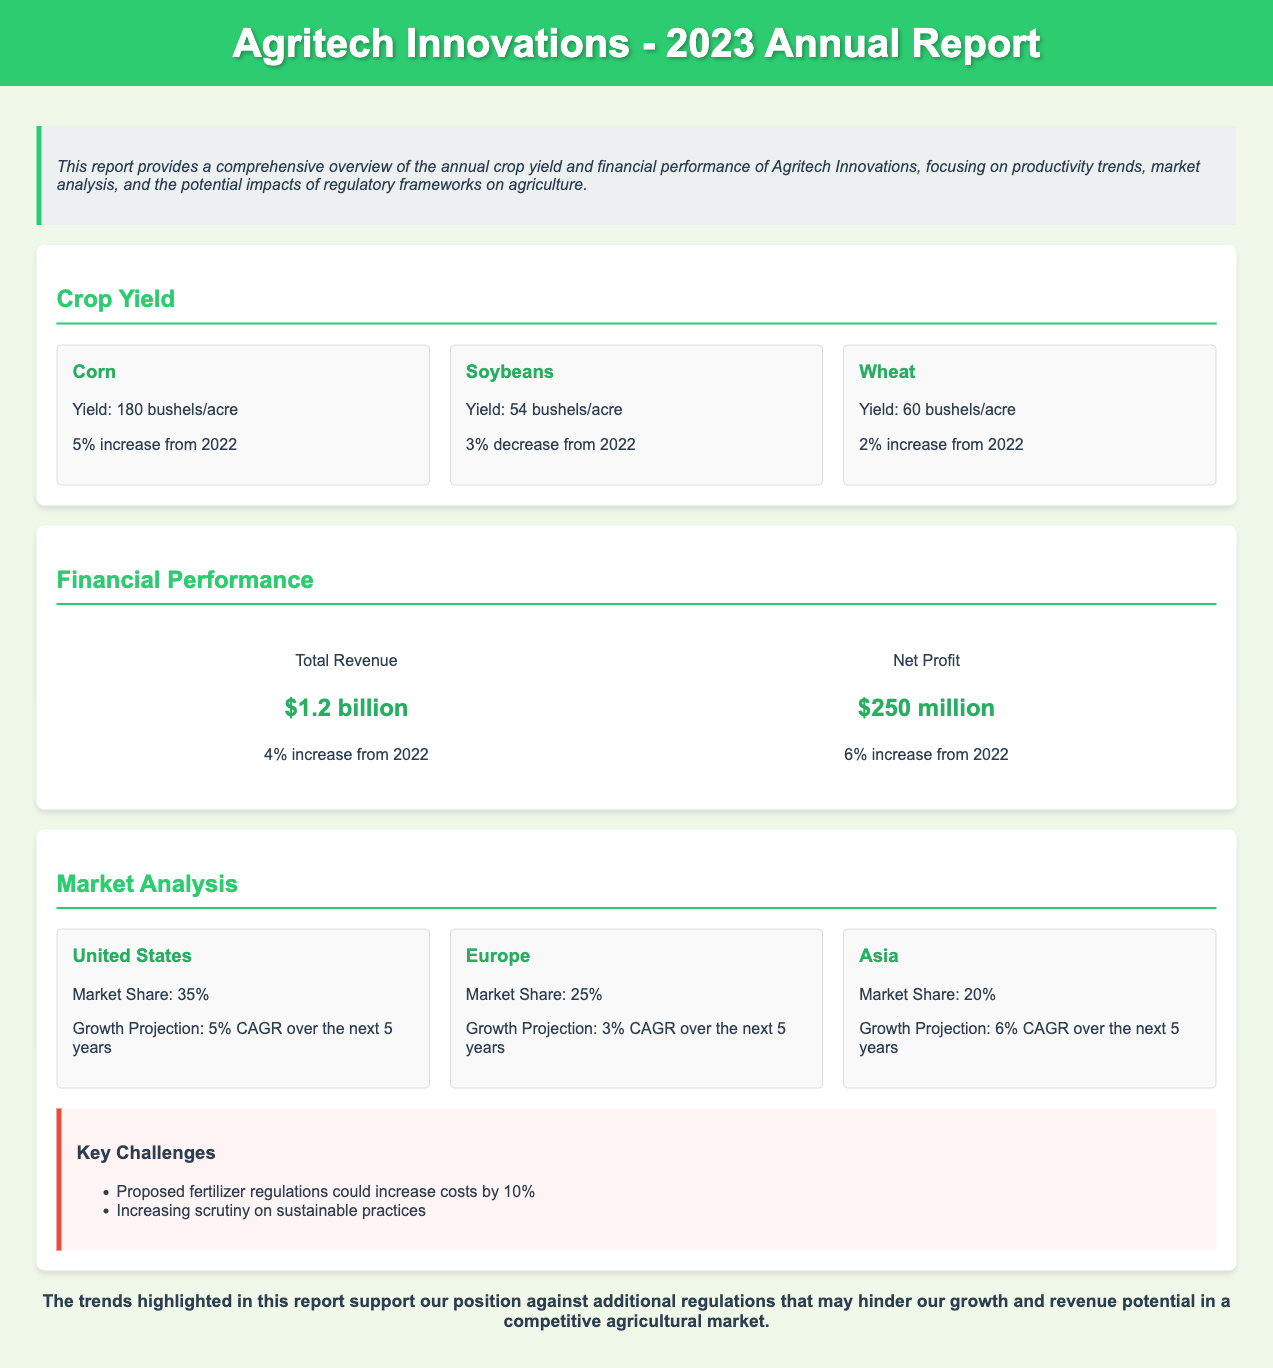what is the corn yield? The corn yield is specified in the crop yield section of the document.
Answer: 180 bushels/acre what is the financial performance net profit? The net profit is mentioned under the financial performance section of the document.
Answer: $250 million how much did soybean yield change from 2022? The change in soybean yield is noted in the crop yield section, indicating a percentage change.
Answer: 3% decrease what is the market share in the United States? The market share for the United States is provided in the market analysis section of the document.
Answer: 35% what is the projected growth rate in Asia? The growth rate for Asia is stated in the market analysis section regarding future projections.
Answer: 6% CAGR what is the total revenue? The total revenue figure is highlighted in the financial performance section of the document.
Answer: $1.2 billion what are the key challenges mentioned? The key challenges are listed in the market analysis section, outlining specific regulatory challenges.
Answer: Proposed fertilizer regulations what is the percentage increase in corn yield from 2022? The percentage increase for corn yield is detailed in the crop yield section of the report.
Answer: 5% increase what conclusion does the report support? The conclusion addresses the overall stance on regulations and their impact on growth.
Answer: Against additional regulations 